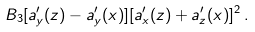Convert formula to latex. <formula><loc_0><loc_0><loc_500><loc_500>B _ { 3 } [ a ^ { \prime } _ { y } ( z ) - a ^ { \prime } _ { y } ( x ) ] [ a ^ { \prime } _ { x } ( z ) + a ^ { \prime } _ { z } ( x ) ] ^ { 2 } \, .</formula> 